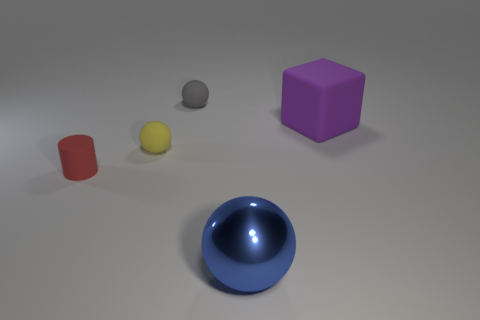Add 3 cubes. How many objects exist? 8 Subtract all spheres. How many objects are left? 2 Add 2 rubber blocks. How many rubber blocks are left? 3 Add 2 large metal spheres. How many large metal spheres exist? 3 Subtract 1 red cylinders. How many objects are left? 4 Subtract all big gray matte blocks. Subtract all tiny objects. How many objects are left? 2 